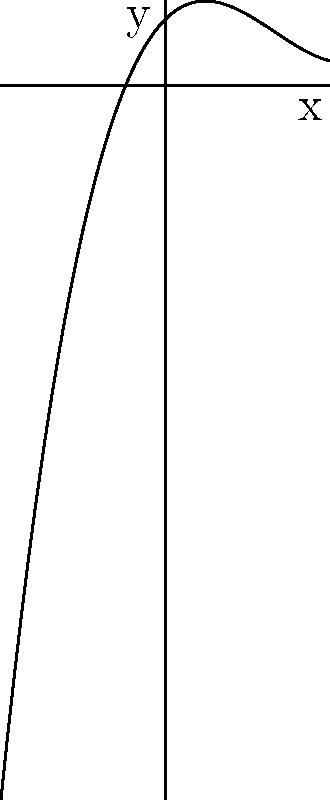As you monitor the graph of your baby's heart rate during labor, you notice it resembles a polynomial function. The nurse explains that the end behavior of the graph can indicate the degree of the polynomial, similar to how certain vital signs trends can suggest the progression of labor. Based on the end behavior of the polynomial graph shown, what is the degree of this polynomial? To determine the degree of a polynomial based on its end behavior, we need to follow these steps:

1. Observe the behavior of the graph as $x$ approaches positive and negative infinity.
2. Compare this behavior to known end behaviors of polynomials:
   - Linear (degree 1): One end up, one end down
   - Quadratic (degree 2): Both ends up or both ends down
   - Cubic (degree 3): One end up, one end down (opposite to linear)
   - Quartic (degree 4): Both ends up
   - Odd degree: Opposite end behaviors
   - Even degree: Same end behaviors

3. In this graph, we can see that:
   - As $x$ approaches positive infinity, $y$ approaches positive infinity
   - As $x$ approaches negative infinity, $y$ approaches negative infinity

4. This behavior (one end up, one end down, but opposite to linear) is characteristic of a cubic polynomial.

Therefore, the degree of this polynomial is 3.
Answer: 3 